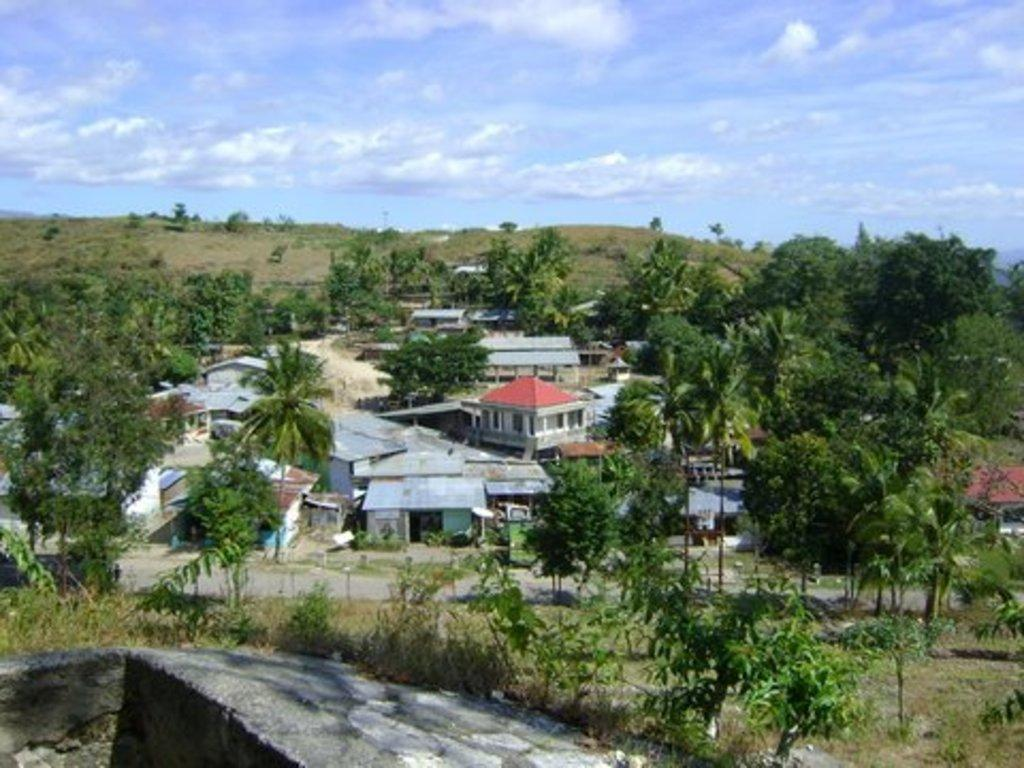What is the main feature of the image? There is a road in the image. What type of structures can be seen along the road? There are buildings with windows in the image. What natural elements are present in the image? There are trees and grass in the image. What can be seen in the background of the image? The sky is visible in the background of the image, and there are clouds in the sky. What type of produce is being harvested in the image? There is no produce being harvested in the image; it features a road, buildings, trees, grass, and a sky with clouds. What role does the key play in the image? There is no key present in the image. 